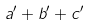Convert formula to latex. <formula><loc_0><loc_0><loc_500><loc_500>a ^ { \prime } + b ^ { \prime } + c ^ { \prime }</formula> 